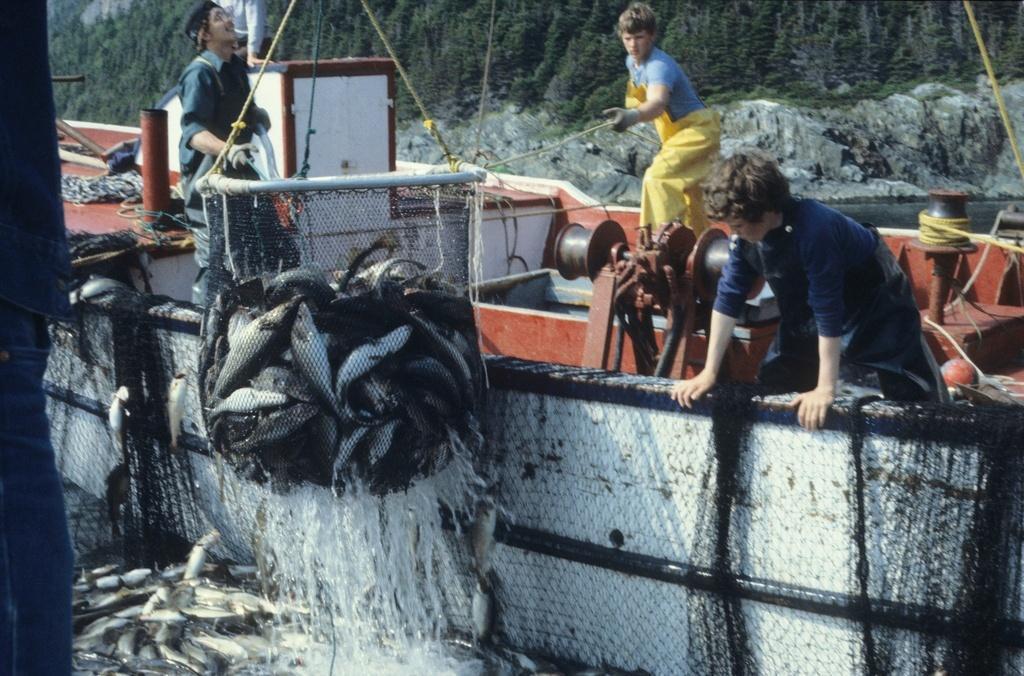Describe this image in one or two sentences. In this image I can see number of fish where few are on the ground and few are in the fishing net. I can also see water in the front and in the background I can see three persons, few ropes and number of trees. 